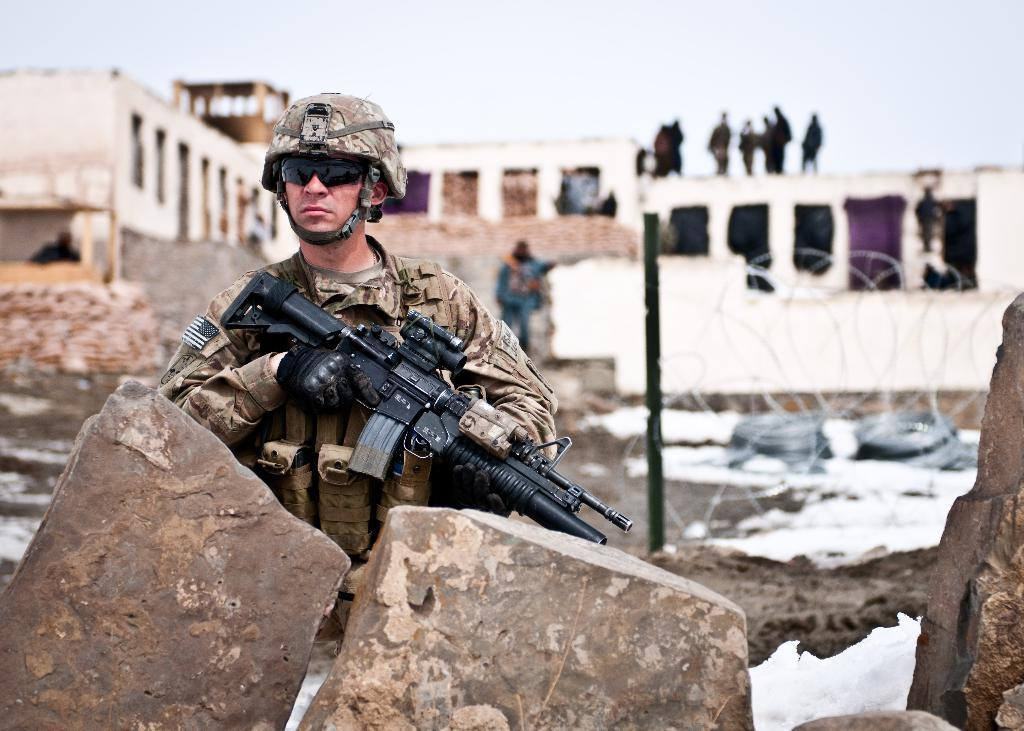What is the main subject of the image? There is an army soldier in the image. What is the soldier holding in his hand? The soldier is holding a gun in his hand. What can be seen in the background of the image? There are buildings visible in the background of the image. What are the people doing on the buildings in the background? There are people standing on the buildings in the background. What type of mist can be seen surrounding the soldier in the image? There is no mist present in the image; it is a clear scene with the soldier holding a gun and buildings visible in the background. 